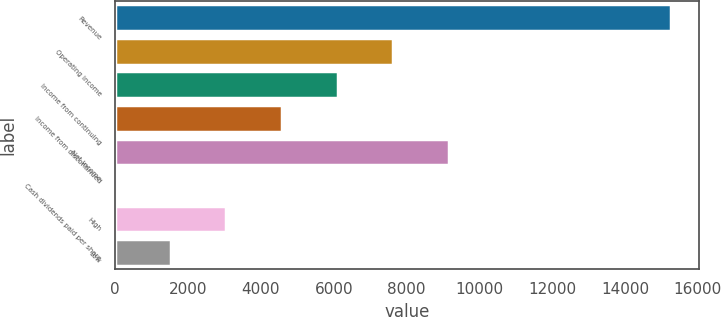<chart> <loc_0><loc_0><loc_500><loc_500><bar_chart><fcel>Revenue<fcel>Operating income<fcel>Income from continuing<fcel>Income from discontinued<fcel>Net income<fcel>Cash dividends paid per share<fcel>High<fcel>Low<nl><fcel>15264<fcel>7632.19<fcel>6105.82<fcel>4579.45<fcel>9158.56<fcel>0.34<fcel>3053.08<fcel>1526.71<nl></chart> 